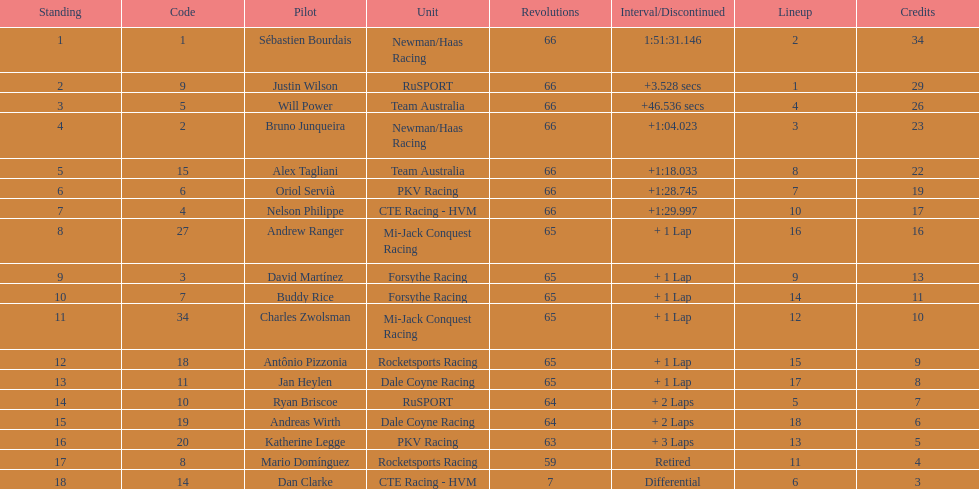What is the number of laps dan clarke completed? 7. 